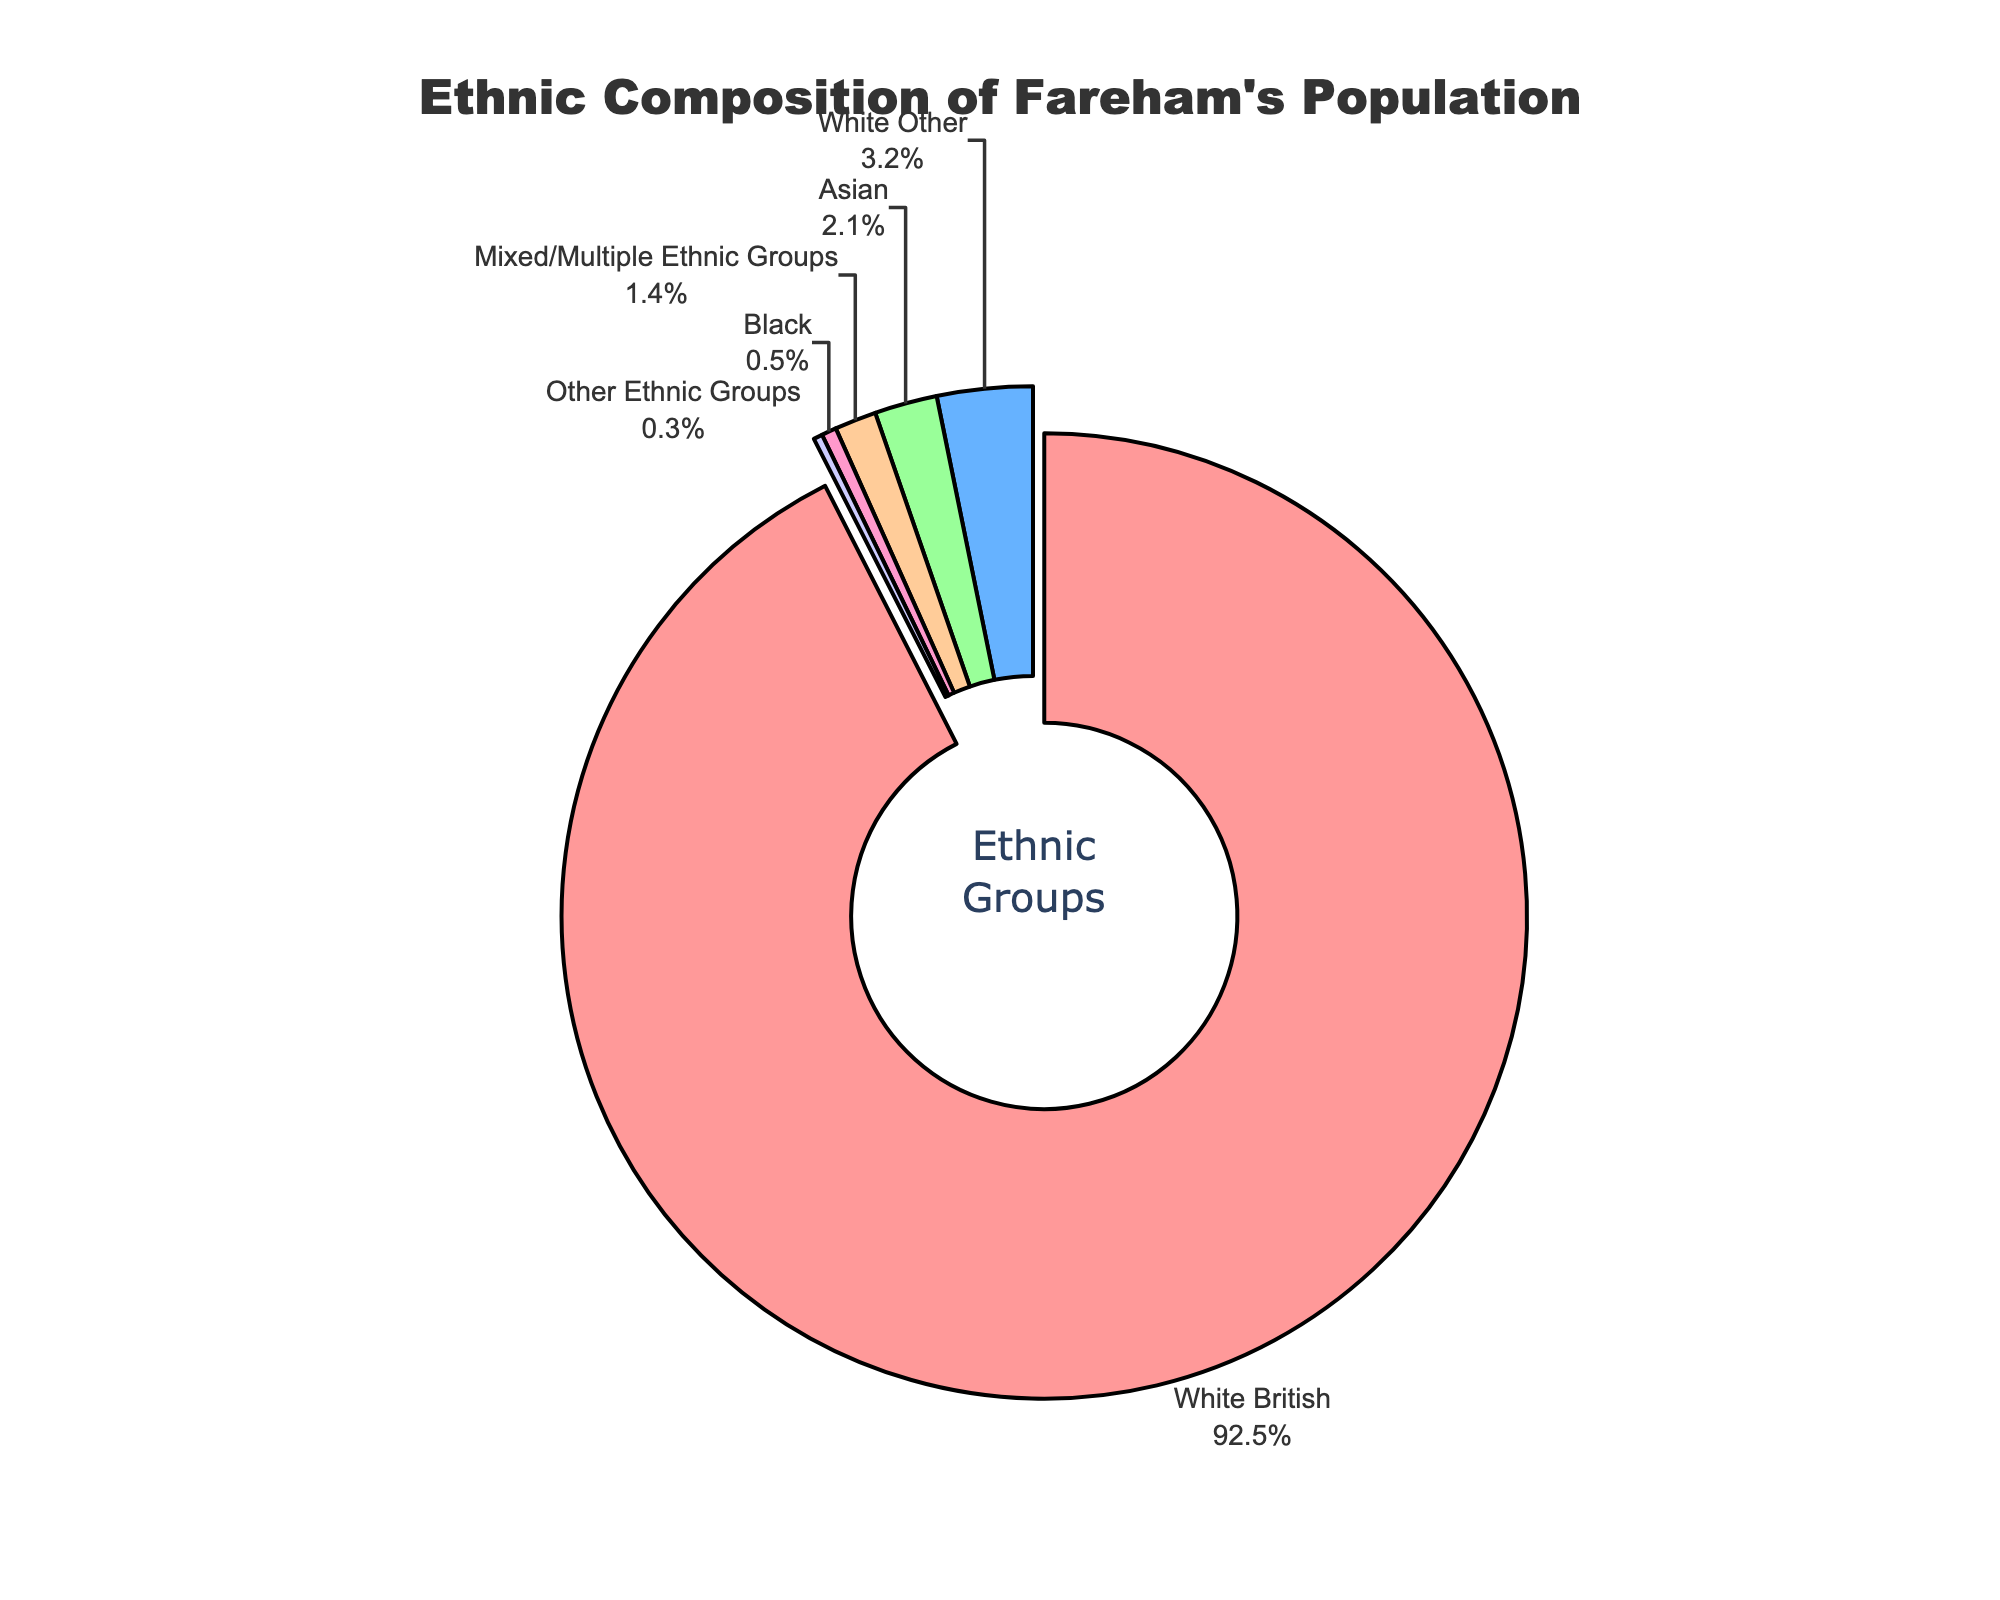What's the largest ethnic group in Fareham? The figure shows that the biggest segment, indicated by a color (likely the first one listed for its size and pull effect), represents the White British group, encompassing 92.5% of the population.
Answer: White British What percentage of Fareham's population is made up of the two smallest ethnic groups combined? The two smallest ethnic groups are Other Ethnic Groups (0.3%) and Black (0.5%). Adding these percentages: 0.3% + 0.5% = 0.8%.
Answer: 0.8% How much larger is the White British group compared to the Asian group? The White British group is 92.5%, and the Asian group is 2.1%. The difference between them is 92.5% - 2.1% = 90.4%.
Answer: 90.4% How many ethnic groups make up less than 2% of Fareham's population each? Referencing the percentages, three groups have less than 2% each: Asian (2.1% is slightly over the threshold), Mixed/Multiple Ethnic Groups (1.4%), Black (0.5%), and Other Ethnic Groups (0.3%). Therefore, the count is 3.
Answer: 3 Which ethnic group has a visual feature like being pulled out from the center? The segment visually separated a bit is usually emphasized for significance; it represents the White British group, the largest segment at 92.5%.
Answer: White British What is the visual color associated with the White Other ethnic group? In the visual, the White Other group, being the second largest, would follow in a prominent color like blue, indicated second in the colors list.
Answer: Likely blue What is the cumulative percentage of all groups other than White British? The sum of the percentages for all other ethnic groups: 3.2% (White Other) + 2.1% (Asian) + 1.4% (Mixed/Multiple) + 0.5% (Black) + 0.3% (Other Ethnic Groups) = 7.5%.
Answer: 7.5% Is there a significant percentage disparity between the White Other and Asian groups? Yes, White Other is 3.2% while Asian is 2.1%, indicating a difference of 1.1%.
Answer: Yes Which group has the smallest segment and what percentage does it represent? The smallest segment is labeled Other Ethnic Groups, which represents 0.3% of the population.
Answer: Other Ethnic Groups, 0.3% Does any ethnic group individually surpass the sum of all the smaller groups? The White British group, at 92.5%, far exceeds the combined total of all other groups, which amounts to 7.5%.
Answer: Yes 